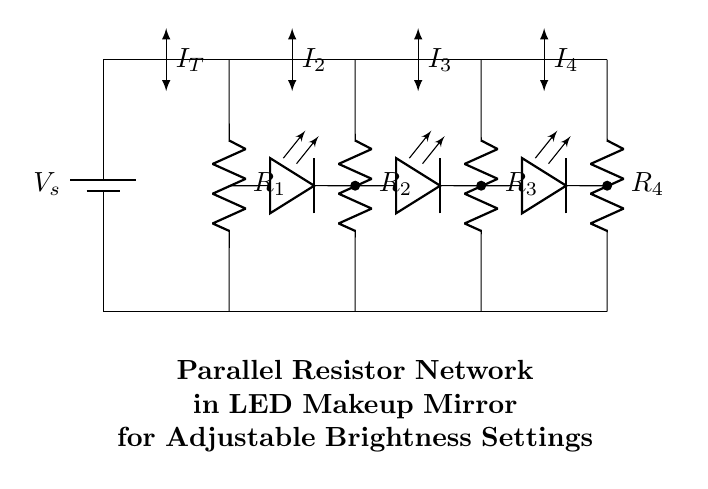What is the total voltage supplied to the circuit? The total voltage supplied to the circuit is indicated at the power source, represented by \( V_s \). There are no other components altering this voltage in the circuit diagram.
Answer: Vs How many resistors are present in the parallel network? There are four resistors labeled \( R_1, R_2, R_3, \) and \( R_4 \). Each resistor is connected in parallel with the others, contributing to the current distribution.
Answer: Four What happens to the brightness if \( R_2 \) is removed? Removing \( R_2 \) will increase the total resistance of the parallel network, which will decrease the current flowing through the circuit due to Ohm's law. However, the remaining resistors will continue to provide some current, affecting the overall LED brightness. Essentially, the total current will decrease, and with it, the brightness of the LEDs will lower accordingly.
Answer: Decrease What is the relationship between the total current (\( I_T \)) and the individual currents (\( I_2, I_3, I_4 \))? The total current \( I_T \) is equal to the sum of the individual currents through the resistors: \( I_T = I_2 + I_3 + I_4 \). This relationship follows from Kirchhoff's current law, which states that the total current entering a junction equals the total current leaving that junction.
Answer: I_T = I_2 + I_3 + I_4 Which resistor has the least impact on total current if increased? In a parallel circuit, the resistor with the smallest resistance value impacts the total current the least when increased because the overall current is dominated by the path of least resistance. If \( R_1 \) has a significantly lower resistance, adjusting its value will have minimal effect on total current distribution.
Answer: R1 